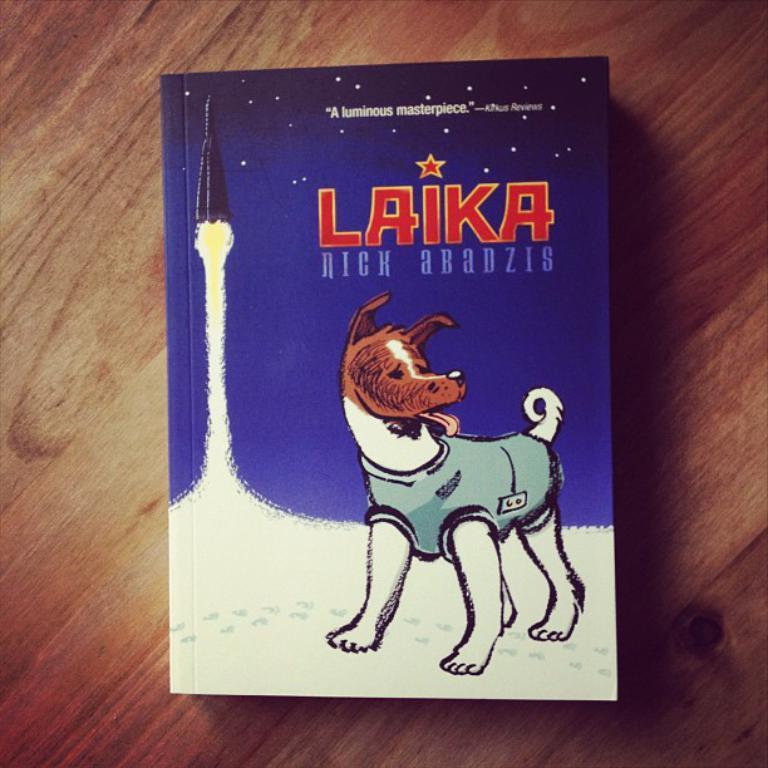Describe this image in one or two sentences. In the center of the image there is a book placed on the table. 